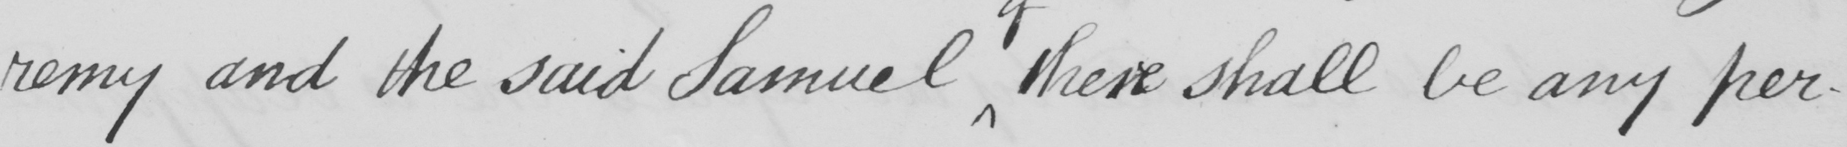Can you read and transcribe this handwriting? -remy and the said Samuel there shall be any per- 